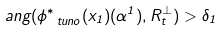Convert formula to latex. <formula><loc_0><loc_0><loc_500><loc_500>a n g ( \phi _ { \ t u n o } ^ { \ast } ( x _ { 1 } ) ( \alpha ^ { 1 } ) , R _ { t } ^ { \perp } ) > \delta _ { 1 }</formula> 